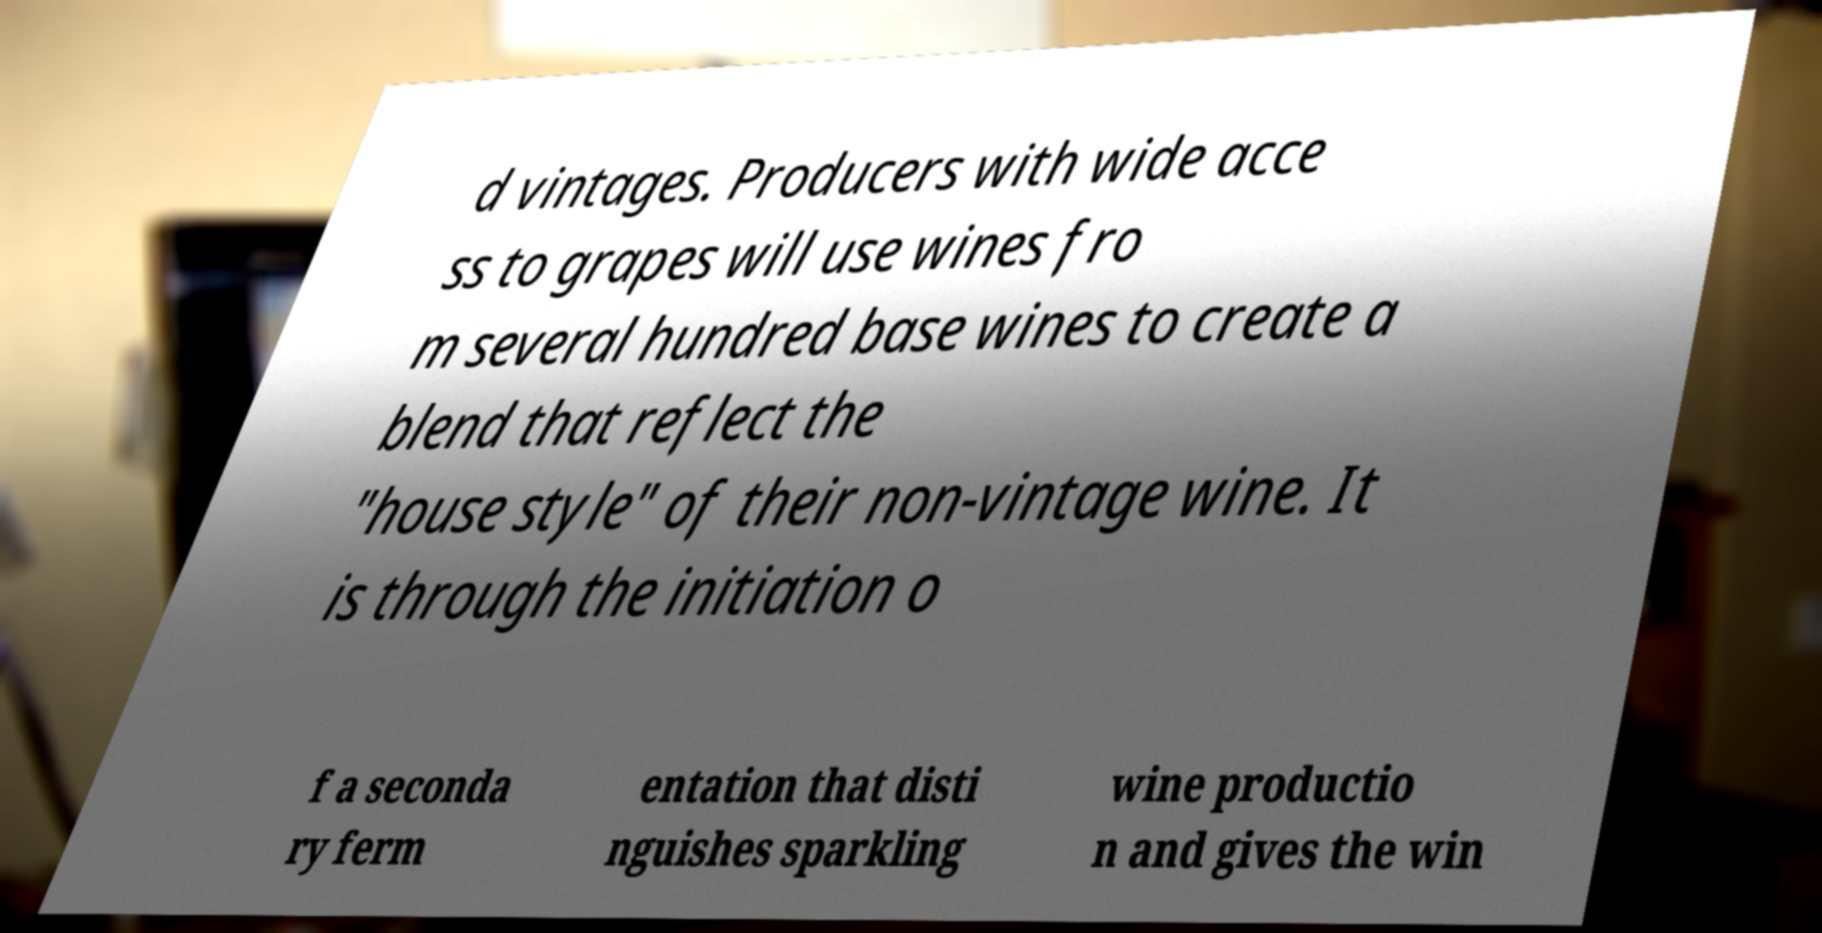For documentation purposes, I need the text within this image transcribed. Could you provide that? d vintages. Producers with wide acce ss to grapes will use wines fro m several hundred base wines to create a blend that reflect the "house style" of their non-vintage wine. It is through the initiation o f a seconda ry ferm entation that disti nguishes sparkling wine productio n and gives the win 